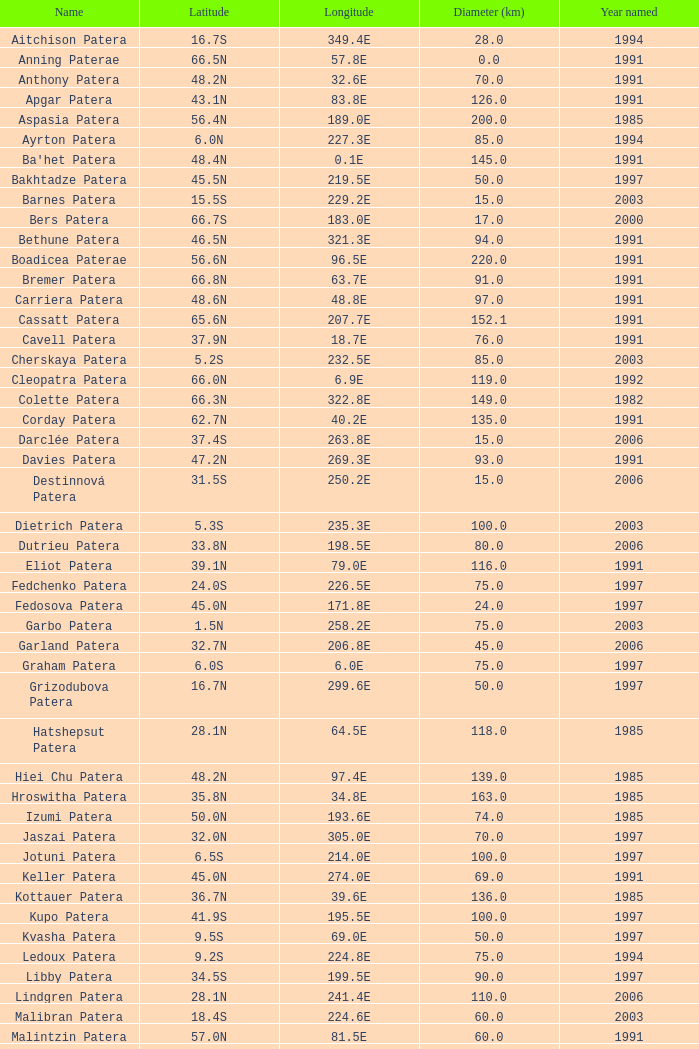What is the mean year named, when latitude is 3 None. 